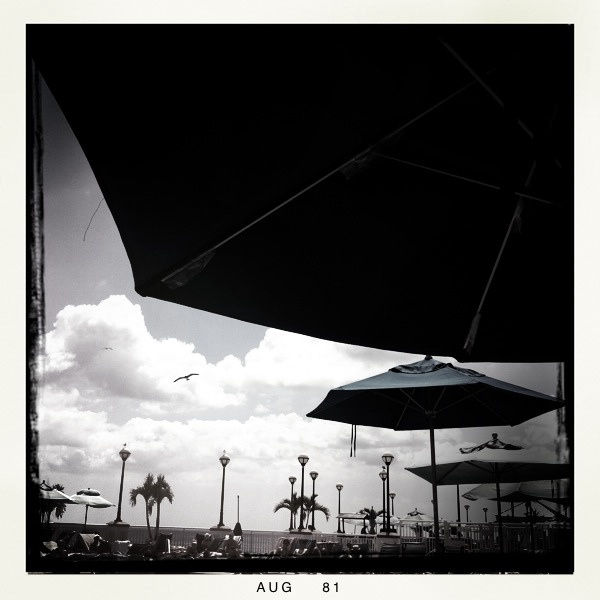Describe the objects in this image and their specific colors. I can see umbrella in ivory, black, lightgray, and darkgray tones, umbrella in ivory, black, and gray tones, umbrella in ivory, black, gray, darkgray, and lightgray tones, umbrella in ivory and black tones, and umbrella in ivory, black, darkgray, gray, and white tones in this image. 